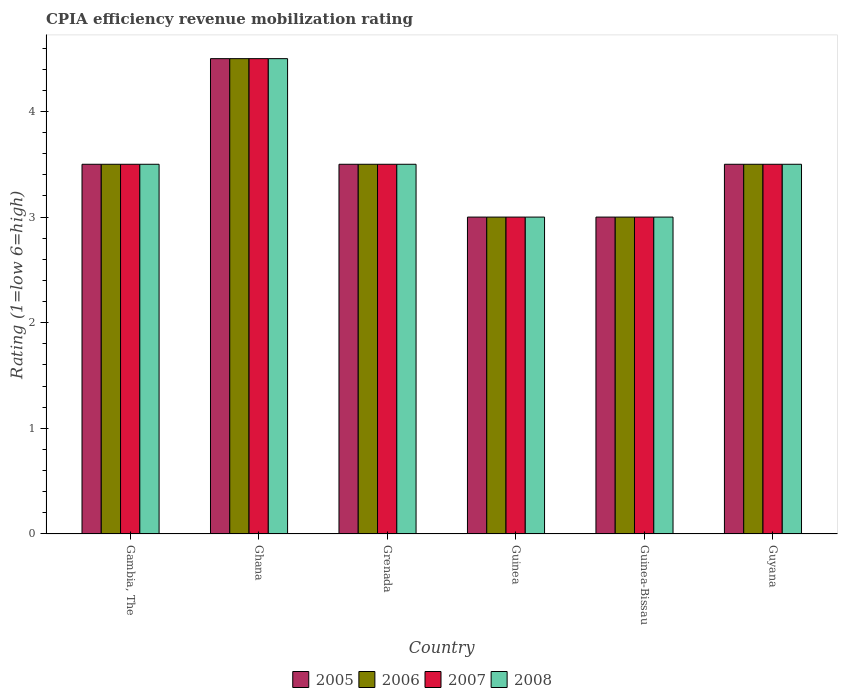Are the number of bars per tick equal to the number of legend labels?
Ensure brevity in your answer.  Yes. How many bars are there on the 5th tick from the left?
Provide a short and direct response. 4. How many bars are there on the 3rd tick from the right?
Offer a terse response. 4. What is the label of the 2nd group of bars from the left?
Keep it short and to the point. Ghana. In how many cases, is the number of bars for a given country not equal to the number of legend labels?
Make the answer very short. 0. In which country was the CPIA rating in 2008 maximum?
Your response must be concise. Ghana. In which country was the CPIA rating in 2008 minimum?
Provide a succinct answer. Guinea. What is the total CPIA rating in 2008 in the graph?
Your answer should be compact. 21. What is the difference between the CPIA rating in 2005 in Guinea and that in Guyana?
Give a very brief answer. -0.5. What is the difference between the CPIA rating in 2006 in Grenada and the CPIA rating in 2007 in Ghana?
Keep it short and to the point. -1. What is the ratio of the CPIA rating in 2007 in Gambia, The to that in Grenada?
Offer a very short reply. 1. Is the CPIA rating in 2005 in Gambia, The less than that in Guinea?
Provide a short and direct response. No. In how many countries, is the CPIA rating in 2005 greater than the average CPIA rating in 2005 taken over all countries?
Your answer should be compact. 1. What does the 1st bar from the right in Ghana represents?
Your response must be concise. 2008. How many bars are there?
Offer a very short reply. 24. Are all the bars in the graph horizontal?
Give a very brief answer. No. Are the values on the major ticks of Y-axis written in scientific E-notation?
Provide a succinct answer. No. How are the legend labels stacked?
Keep it short and to the point. Horizontal. What is the title of the graph?
Offer a terse response. CPIA efficiency revenue mobilization rating. Does "2007" appear as one of the legend labels in the graph?
Offer a terse response. Yes. What is the label or title of the X-axis?
Provide a short and direct response. Country. What is the Rating (1=low 6=high) of 2006 in Gambia, The?
Your answer should be very brief. 3.5. What is the Rating (1=low 6=high) of 2007 in Gambia, The?
Your answer should be compact. 3.5. What is the Rating (1=low 6=high) of 2008 in Ghana?
Your answer should be very brief. 4.5. What is the Rating (1=low 6=high) in 2005 in Grenada?
Your answer should be very brief. 3.5. What is the Rating (1=low 6=high) of 2008 in Grenada?
Make the answer very short. 3.5. What is the Rating (1=low 6=high) of 2006 in Guinea?
Ensure brevity in your answer.  3. What is the Rating (1=low 6=high) of 2005 in Guinea-Bissau?
Offer a terse response. 3. What is the Rating (1=low 6=high) of 2006 in Guinea-Bissau?
Your answer should be very brief. 3. What is the Rating (1=low 6=high) in 2007 in Guinea-Bissau?
Provide a short and direct response. 3. What is the Rating (1=low 6=high) of 2006 in Guyana?
Provide a succinct answer. 3.5. What is the Rating (1=low 6=high) of 2008 in Guyana?
Your response must be concise. 3.5. Across all countries, what is the maximum Rating (1=low 6=high) of 2006?
Your response must be concise. 4.5. Across all countries, what is the maximum Rating (1=low 6=high) in 2007?
Offer a very short reply. 4.5. Across all countries, what is the minimum Rating (1=low 6=high) of 2007?
Give a very brief answer. 3. What is the total Rating (1=low 6=high) in 2005 in the graph?
Make the answer very short. 21. What is the total Rating (1=low 6=high) of 2007 in the graph?
Your answer should be compact. 21. What is the total Rating (1=low 6=high) of 2008 in the graph?
Provide a succinct answer. 21. What is the difference between the Rating (1=low 6=high) of 2005 in Gambia, The and that in Ghana?
Your answer should be compact. -1. What is the difference between the Rating (1=low 6=high) of 2007 in Gambia, The and that in Ghana?
Ensure brevity in your answer.  -1. What is the difference between the Rating (1=low 6=high) of 2008 in Gambia, The and that in Ghana?
Your response must be concise. -1. What is the difference between the Rating (1=low 6=high) of 2005 in Gambia, The and that in Grenada?
Your answer should be compact. 0. What is the difference between the Rating (1=low 6=high) in 2006 in Gambia, The and that in Grenada?
Your answer should be very brief. 0. What is the difference between the Rating (1=low 6=high) of 2008 in Gambia, The and that in Grenada?
Keep it short and to the point. 0. What is the difference between the Rating (1=low 6=high) of 2006 in Gambia, The and that in Guinea?
Your answer should be very brief. 0.5. What is the difference between the Rating (1=low 6=high) of 2006 in Gambia, The and that in Guinea-Bissau?
Your answer should be compact. 0.5. What is the difference between the Rating (1=low 6=high) of 2005 in Gambia, The and that in Guyana?
Offer a very short reply. 0. What is the difference between the Rating (1=low 6=high) of 2007 in Gambia, The and that in Guyana?
Provide a succinct answer. 0. What is the difference between the Rating (1=low 6=high) of 2008 in Gambia, The and that in Guyana?
Keep it short and to the point. 0. What is the difference between the Rating (1=low 6=high) of 2006 in Ghana and that in Grenada?
Your answer should be very brief. 1. What is the difference between the Rating (1=low 6=high) of 2007 in Ghana and that in Grenada?
Offer a very short reply. 1. What is the difference between the Rating (1=low 6=high) of 2006 in Ghana and that in Guinea?
Offer a terse response. 1.5. What is the difference between the Rating (1=low 6=high) in 2008 in Ghana and that in Guinea?
Your answer should be compact. 1.5. What is the difference between the Rating (1=low 6=high) of 2007 in Ghana and that in Guinea-Bissau?
Ensure brevity in your answer.  1.5. What is the difference between the Rating (1=low 6=high) of 2008 in Ghana and that in Guinea-Bissau?
Provide a short and direct response. 1.5. What is the difference between the Rating (1=low 6=high) in 2008 in Ghana and that in Guyana?
Make the answer very short. 1. What is the difference between the Rating (1=low 6=high) in 2005 in Grenada and that in Guinea?
Offer a terse response. 0.5. What is the difference between the Rating (1=low 6=high) in 2007 in Grenada and that in Guinea?
Give a very brief answer. 0.5. What is the difference between the Rating (1=low 6=high) of 2006 in Grenada and that in Guinea-Bissau?
Keep it short and to the point. 0.5. What is the difference between the Rating (1=low 6=high) in 2005 in Grenada and that in Guyana?
Provide a succinct answer. 0. What is the difference between the Rating (1=low 6=high) of 2006 in Grenada and that in Guyana?
Offer a terse response. 0. What is the difference between the Rating (1=low 6=high) in 2005 in Guinea and that in Guinea-Bissau?
Provide a short and direct response. 0. What is the difference between the Rating (1=low 6=high) in 2006 in Guinea and that in Guinea-Bissau?
Your answer should be very brief. 0. What is the difference between the Rating (1=low 6=high) of 2008 in Guinea and that in Guinea-Bissau?
Make the answer very short. 0. What is the difference between the Rating (1=low 6=high) of 2005 in Guinea and that in Guyana?
Ensure brevity in your answer.  -0.5. What is the difference between the Rating (1=low 6=high) in 2007 in Guinea and that in Guyana?
Your response must be concise. -0.5. What is the difference between the Rating (1=low 6=high) of 2005 in Guinea-Bissau and that in Guyana?
Keep it short and to the point. -0.5. What is the difference between the Rating (1=low 6=high) in 2006 in Guinea-Bissau and that in Guyana?
Provide a short and direct response. -0.5. What is the difference between the Rating (1=low 6=high) of 2008 in Guinea-Bissau and that in Guyana?
Your answer should be very brief. -0.5. What is the difference between the Rating (1=low 6=high) in 2005 in Gambia, The and the Rating (1=low 6=high) in 2006 in Ghana?
Provide a short and direct response. -1. What is the difference between the Rating (1=low 6=high) in 2005 in Gambia, The and the Rating (1=low 6=high) in 2007 in Ghana?
Give a very brief answer. -1. What is the difference between the Rating (1=low 6=high) of 2006 in Gambia, The and the Rating (1=low 6=high) of 2007 in Ghana?
Provide a succinct answer. -1. What is the difference between the Rating (1=low 6=high) in 2005 in Gambia, The and the Rating (1=low 6=high) in 2006 in Grenada?
Provide a short and direct response. 0. What is the difference between the Rating (1=low 6=high) of 2005 in Gambia, The and the Rating (1=low 6=high) of 2007 in Grenada?
Provide a short and direct response. 0. What is the difference between the Rating (1=low 6=high) in 2005 in Gambia, The and the Rating (1=low 6=high) in 2008 in Grenada?
Ensure brevity in your answer.  0. What is the difference between the Rating (1=low 6=high) of 2006 in Gambia, The and the Rating (1=low 6=high) of 2007 in Grenada?
Give a very brief answer. 0. What is the difference between the Rating (1=low 6=high) of 2006 in Gambia, The and the Rating (1=low 6=high) of 2008 in Grenada?
Keep it short and to the point. 0. What is the difference between the Rating (1=low 6=high) of 2005 in Gambia, The and the Rating (1=low 6=high) of 2006 in Guinea?
Provide a short and direct response. 0.5. What is the difference between the Rating (1=low 6=high) in 2006 in Gambia, The and the Rating (1=low 6=high) in 2007 in Guinea?
Give a very brief answer. 0.5. What is the difference between the Rating (1=low 6=high) in 2005 in Gambia, The and the Rating (1=low 6=high) in 2006 in Guinea-Bissau?
Your answer should be compact. 0.5. What is the difference between the Rating (1=low 6=high) of 2005 in Gambia, The and the Rating (1=low 6=high) of 2007 in Guyana?
Give a very brief answer. 0. What is the difference between the Rating (1=low 6=high) of 2006 in Gambia, The and the Rating (1=low 6=high) of 2007 in Guyana?
Make the answer very short. 0. What is the difference between the Rating (1=low 6=high) in 2005 in Ghana and the Rating (1=low 6=high) in 2008 in Grenada?
Keep it short and to the point. 1. What is the difference between the Rating (1=low 6=high) of 2006 in Ghana and the Rating (1=low 6=high) of 2008 in Grenada?
Provide a succinct answer. 1. What is the difference between the Rating (1=low 6=high) of 2005 in Ghana and the Rating (1=low 6=high) of 2006 in Guinea?
Provide a short and direct response. 1.5. What is the difference between the Rating (1=low 6=high) in 2006 in Ghana and the Rating (1=low 6=high) in 2007 in Guinea?
Offer a very short reply. 1.5. What is the difference between the Rating (1=low 6=high) in 2006 in Ghana and the Rating (1=low 6=high) in 2008 in Guinea?
Offer a very short reply. 1.5. What is the difference between the Rating (1=low 6=high) in 2005 in Ghana and the Rating (1=low 6=high) in 2006 in Guinea-Bissau?
Your answer should be compact. 1.5. What is the difference between the Rating (1=low 6=high) in 2005 in Ghana and the Rating (1=low 6=high) in 2008 in Guinea-Bissau?
Keep it short and to the point. 1.5. What is the difference between the Rating (1=low 6=high) in 2006 in Ghana and the Rating (1=low 6=high) in 2008 in Guinea-Bissau?
Make the answer very short. 1.5. What is the difference between the Rating (1=low 6=high) in 2007 in Ghana and the Rating (1=low 6=high) in 2008 in Guinea-Bissau?
Your answer should be compact. 1.5. What is the difference between the Rating (1=low 6=high) of 2006 in Ghana and the Rating (1=low 6=high) of 2008 in Guyana?
Your response must be concise. 1. What is the difference between the Rating (1=low 6=high) of 2006 in Grenada and the Rating (1=low 6=high) of 2008 in Guinea?
Make the answer very short. 0.5. What is the difference between the Rating (1=low 6=high) of 2007 in Grenada and the Rating (1=low 6=high) of 2008 in Guinea?
Your answer should be compact. 0.5. What is the difference between the Rating (1=low 6=high) of 2005 in Grenada and the Rating (1=low 6=high) of 2006 in Guinea-Bissau?
Make the answer very short. 0.5. What is the difference between the Rating (1=low 6=high) in 2005 in Grenada and the Rating (1=low 6=high) in 2007 in Guinea-Bissau?
Your answer should be compact. 0.5. What is the difference between the Rating (1=low 6=high) of 2006 in Grenada and the Rating (1=low 6=high) of 2007 in Guinea-Bissau?
Ensure brevity in your answer.  0.5. What is the difference between the Rating (1=low 6=high) in 2006 in Grenada and the Rating (1=low 6=high) in 2007 in Guyana?
Offer a very short reply. 0. What is the difference between the Rating (1=low 6=high) in 2007 in Grenada and the Rating (1=low 6=high) in 2008 in Guyana?
Make the answer very short. 0. What is the difference between the Rating (1=low 6=high) in 2005 in Guinea and the Rating (1=low 6=high) in 2006 in Guinea-Bissau?
Your response must be concise. 0. What is the difference between the Rating (1=low 6=high) of 2006 in Guinea and the Rating (1=low 6=high) of 2007 in Guinea-Bissau?
Make the answer very short. 0. What is the difference between the Rating (1=low 6=high) of 2005 in Guinea and the Rating (1=low 6=high) of 2006 in Guyana?
Make the answer very short. -0.5. What is the difference between the Rating (1=low 6=high) of 2005 in Guinea and the Rating (1=low 6=high) of 2008 in Guyana?
Provide a succinct answer. -0.5. What is the difference between the Rating (1=low 6=high) in 2007 in Guinea and the Rating (1=low 6=high) in 2008 in Guyana?
Your response must be concise. -0.5. What is the difference between the Rating (1=low 6=high) of 2005 in Guinea-Bissau and the Rating (1=low 6=high) of 2007 in Guyana?
Offer a very short reply. -0.5. What is the average Rating (1=low 6=high) of 2005 per country?
Your answer should be very brief. 3.5. What is the average Rating (1=low 6=high) in 2006 per country?
Offer a very short reply. 3.5. What is the average Rating (1=low 6=high) in 2007 per country?
Your response must be concise. 3.5. What is the average Rating (1=low 6=high) in 2008 per country?
Provide a succinct answer. 3.5. What is the difference between the Rating (1=low 6=high) of 2005 and Rating (1=low 6=high) of 2008 in Gambia, The?
Give a very brief answer. 0. What is the difference between the Rating (1=low 6=high) in 2005 and Rating (1=low 6=high) in 2006 in Ghana?
Make the answer very short. 0. What is the difference between the Rating (1=low 6=high) of 2005 and Rating (1=low 6=high) of 2007 in Ghana?
Offer a very short reply. 0. What is the difference between the Rating (1=low 6=high) in 2005 and Rating (1=low 6=high) in 2008 in Ghana?
Make the answer very short. 0. What is the difference between the Rating (1=low 6=high) of 2006 and Rating (1=low 6=high) of 2007 in Ghana?
Your response must be concise. 0. What is the difference between the Rating (1=low 6=high) in 2007 and Rating (1=low 6=high) in 2008 in Ghana?
Your answer should be compact. 0. What is the difference between the Rating (1=low 6=high) in 2005 and Rating (1=low 6=high) in 2007 in Grenada?
Your response must be concise. 0. What is the difference between the Rating (1=low 6=high) of 2005 and Rating (1=low 6=high) of 2008 in Grenada?
Ensure brevity in your answer.  0. What is the difference between the Rating (1=low 6=high) in 2006 and Rating (1=low 6=high) in 2007 in Grenada?
Give a very brief answer. 0. What is the difference between the Rating (1=low 6=high) of 2007 and Rating (1=low 6=high) of 2008 in Grenada?
Offer a very short reply. 0. What is the difference between the Rating (1=low 6=high) of 2005 and Rating (1=low 6=high) of 2006 in Guinea?
Your response must be concise. 0. What is the difference between the Rating (1=low 6=high) in 2005 and Rating (1=low 6=high) in 2007 in Guinea?
Your answer should be very brief. 0. What is the difference between the Rating (1=low 6=high) in 2005 and Rating (1=low 6=high) in 2008 in Guinea?
Keep it short and to the point. 0. What is the difference between the Rating (1=low 6=high) in 2006 and Rating (1=low 6=high) in 2007 in Guinea?
Provide a short and direct response. 0. What is the difference between the Rating (1=low 6=high) in 2006 and Rating (1=low 6=high) in 2008 in Guinea?
Keep it short and to the point. 0. What is the difference between the Rating (1=low 6=high) in 2005 and Rating (1=low 6=high) in 2006 in Guinea-Bissau?
Offer a very short reply. 0. What is the difference between the Rating (1=low 6=high) in 2005 and Rating (1=low 6=high) in 2007 in Guinea-Bissau?
Your answer should be compact. 0. What is the difference between the Rating (1=low 6=high) in 2006 and Rating (1=low 6=high) in 2008 in Guinea-Bissau?
Give a very brief answer. 0. What is the difference between the Rating (1=low 6=high) in 2005 and Rating (1=low 6=high) in 2006 in Guyana?
Provide a succinct answer. 0. What is the difference between the Rating (1=low 6=high) of 2005 and Rating (1=low 6=high) of 2007 in Guyana?
Your response must be concise. 0. What is the ratio of the Rating (1=low 6=high) of 2007 in Gambia, The to that in Ghana?
Your answer should be very brief. 0.78. What is the ratio of the Rating (1=low 6=high) of 2007 in Gambia, The to that in Grenada?
Provide a short and direct response. 1. What is the ratio of the Rating (1=low 6=high) in 2008 in Gambia, The to that in Grenada?
Provide a short and direct response. 1. What is the ratio of the Rating (1=low 6=high) of 2006 in Gambia, The to that in Guinea?
Offer a very short reply. 1.17. What is the ratio of the Rating (1=low 6=high) of 2007 in Gambia, The to that in Guinea?
Provide a short and direct response. 1.17. What is the ratio of the Rating (1=low 6=high) of 2008 in Gambia, The to that in Guinea?
Your answer should be very brief. 1.17. What is the ratio of the Rating (1=low 6=high) in 2005 in Gambia, The to that in Guinea-Bissau?
Provide a short and direct response. 1.17. What is the ratio of the Rating (1=low 6=high) of 2006 in Gambia, The to that in Guinea-Bissau?
Offer a terse response. 1.17. What is the ratio of the Rating (1=low 6=high) in 2005 in Gambia, The to that in Guyana?
Keep it short and to the point. 1. What is the ratio of the Rating (1=low 6=high) of 2006 in Gambia, The to that in Guyana?
Your response must be concise. 1. What is the ratio of the Rating (1=low 6=high) of 2007 in Gambia, The to that in Guyana?
Make the answer very short. 1. What is the ratio of the Rating (1=low 6=high) in 2008 in Gambia, The to that in Guyana?
Provide a succinct answer. 1. What is the ratio of the Rating (1=low 6=high) of 2005 in Ghana to that in Grenada?
Provide a succinct answer. 1.29. What is the ratio of the Rating (1=low 6=high) of 2008 in Ghana to that in Grenada?
Make the answer very short. 1.29. What is the ratio of the Rating (1=low 6=high) in 2006 in Ghana to that in Guinea?
Your answer should be very brief. 1.5. What is the ratio of the Rating (1=low 6=high) in 2007 in Ghana to that in Guinea?
Your answer should be very brief. 1.5. What is the ratio of the Rating (1=low 6=high) in 2005 in Ghana to that in Guinea-Bissau?
Your answer should be very brief. 1.5. What is the ratio of the Rating (1=low 6=high) of 2008 in Ghana to that in Guinea-Bissau?
Ensure brevity in your answer.  1.5. What is the ratio of the Rating (1=low 6=high) of 2005 in Ghana to that in Guyana?
Provide a succinct answer. 1.29. What is the ratio of the Rating (1=low 6=high) of 2006 in Ghana to that in Guyana?
Your answer should be very brief. 1.29. What is the ratio of the Rating (1=low 6=high) of 2005 in Grenada to that in Guinea?
Provide a short and direct response. 1.17. What is the ratio of the Rating (1=low 6=high) in 2006 in Grenada to that in Guinea?
Give a very brief answer. 1.17. What is the ratio of the Rating (1=low 6=high) of 2007 in Grenada to that in Guinea?
Offer a very short reply. 1.17. What is the ratio of the Rating (1=low 6=high) of 2008 in Grenada to that in Guinea?
Give a very brief answer. 1.17. What is the ratio of the Rating (1=low 6=high) of 2005 in Grenada to that in Guinea-Bissau?
Give a very brief answer. 1.17. What is the ratio of the Rating (1=low 6=high) of 2007 in Grenada to that in Guinea-Bissau?
Offer a very short reply. 1.17. What is the ratio of the Rating (1=low 6=high) of 2008 in Grenada to that in Guinea-Bissau?
Keep it short and to the point. 1.17. What is the ratio of the Rating (1=low 6=high) in 2006 in Grenada to that in Guyana?
Ensure brevity in your answer.  1. What is the ratio of the Rating (1=low 6=high) of 2007 in Grenada to that in Guyana?
Your answer should be compact. 1. What is the ratio of the Rating (1=low 6=high) of 2008 in Grenada to that in Guyana?
Make the answer very short. 1. What is the ratio of the Rating (1=low 6=high) of 2005 in Guinea to that in Guinea-Bissau?
Keep it short and to the point. 1. What is the ratio of the Rating (1=low 6=high) in 2006 in Guinea to that in Guinea-Bissau?
Provide a succinct answer. 1. What is the ratio of the Rating (1=low 6=high) in 2008 in Guinea to that in Guinea-Bissau?
Make the answer very short. 1. What is the ratio of the Rating (1=low 6=high) in 2005 in Guinea to that in Guyana?
Your answer should be compact. 0.86. What is the ratio of the Rating (1=low 6=high) of 2006 in Guinea to that in Guyana?
Make the answer very short. 0.86. What is the ratio of the Rating (1=low 6=high) of 2008 in Guinea to that in Guyana?
Your answer should be very brief. 0.86. What is the ratio of the Rating (1=low 6=high) of 2006 in Guinea-Bissau to that in Guyana?
Keep it short and to the point. 0.86. What is the ratio of the Rating (1=low 6=high) of 2008 in Guinea-Bissau to that in Guyana?
Provide a succinct answer. 0.86. What is the difference between the highest and the second highest Rating (1=low 6=high) in 2005?
Your answer should be very brief. 1. What is the difference between the highest and the second highest Rating (1=low 6=high) in 2006?
Your answer should be very brief. 1. What is the difference between the highest and the lowest Rating (1=low 6=high) of 2007?
Your answer should be very brief. 1.5. 